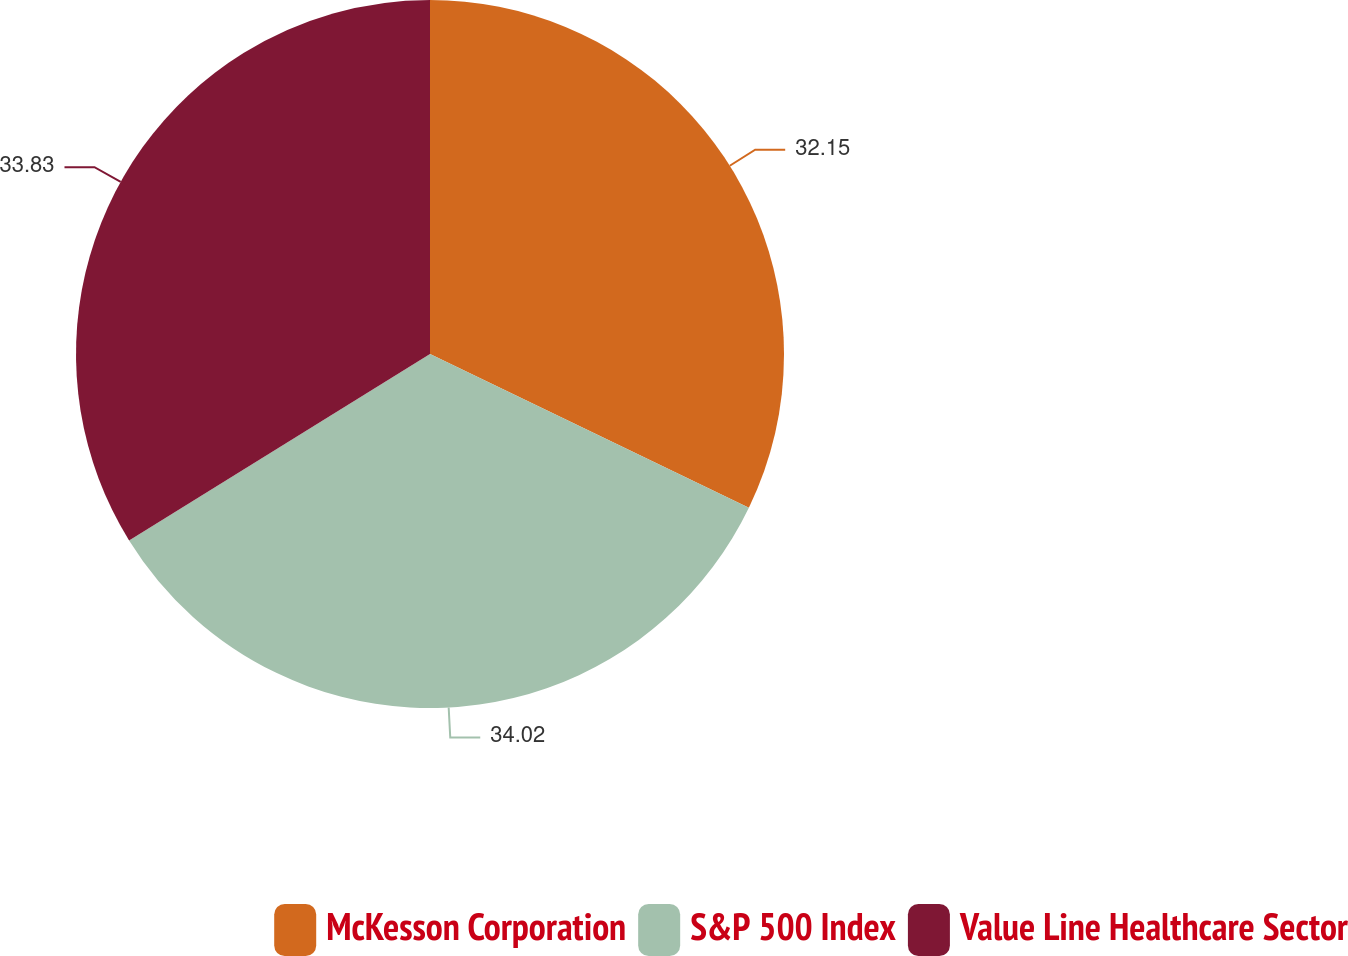<chart> <loc_0><loc_0><loc_500><loc_500><pie_chart><fcel>McKesson Corporation<fcel>S&P 500 Index<fcel>Value Line Healthcare Sector<nl><fcel>32.15%<fcel>34.02%<fcel>33.83%<nl></chart> 